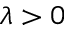<formula> <loc_0><loc_0><loc_500><loc_500>\lambda > 0</formula> 